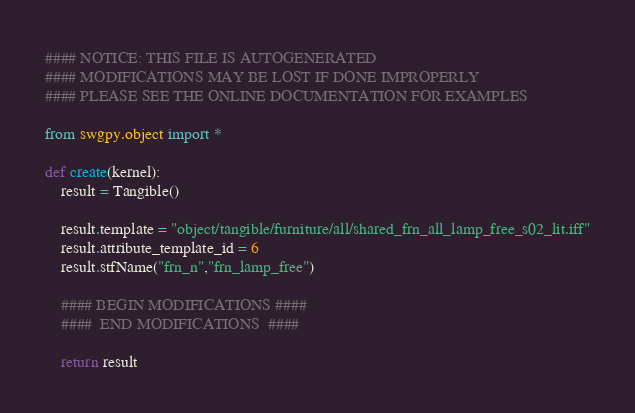Convert code to text. <code><loc_0><loc_0><loc_500><loc_500><_Python_>#### NOTICE: THIS FILE IS AUTOGENERATED
#### MODIFICATIONS MAY BE LOST IF DONE IMPROPERLY
#### PLEASE SEE THE ONLINE DOCUMENTATION FOR EXAMPLES

from swgpy.object import *	

def create(kernel):
	result = Tangible()

	result.template = "object/tangible/furniture/all/shared_frn_all_lamp_free_s02_lit.iff"
	result.attribute_template_id = 6
	result.stfName("frn_n","frn_lamp_free")		
	
	#### BEGIN MODIFICATIONS ####
	####  END MODIFICATIONS  ####
	
	return result</code> 